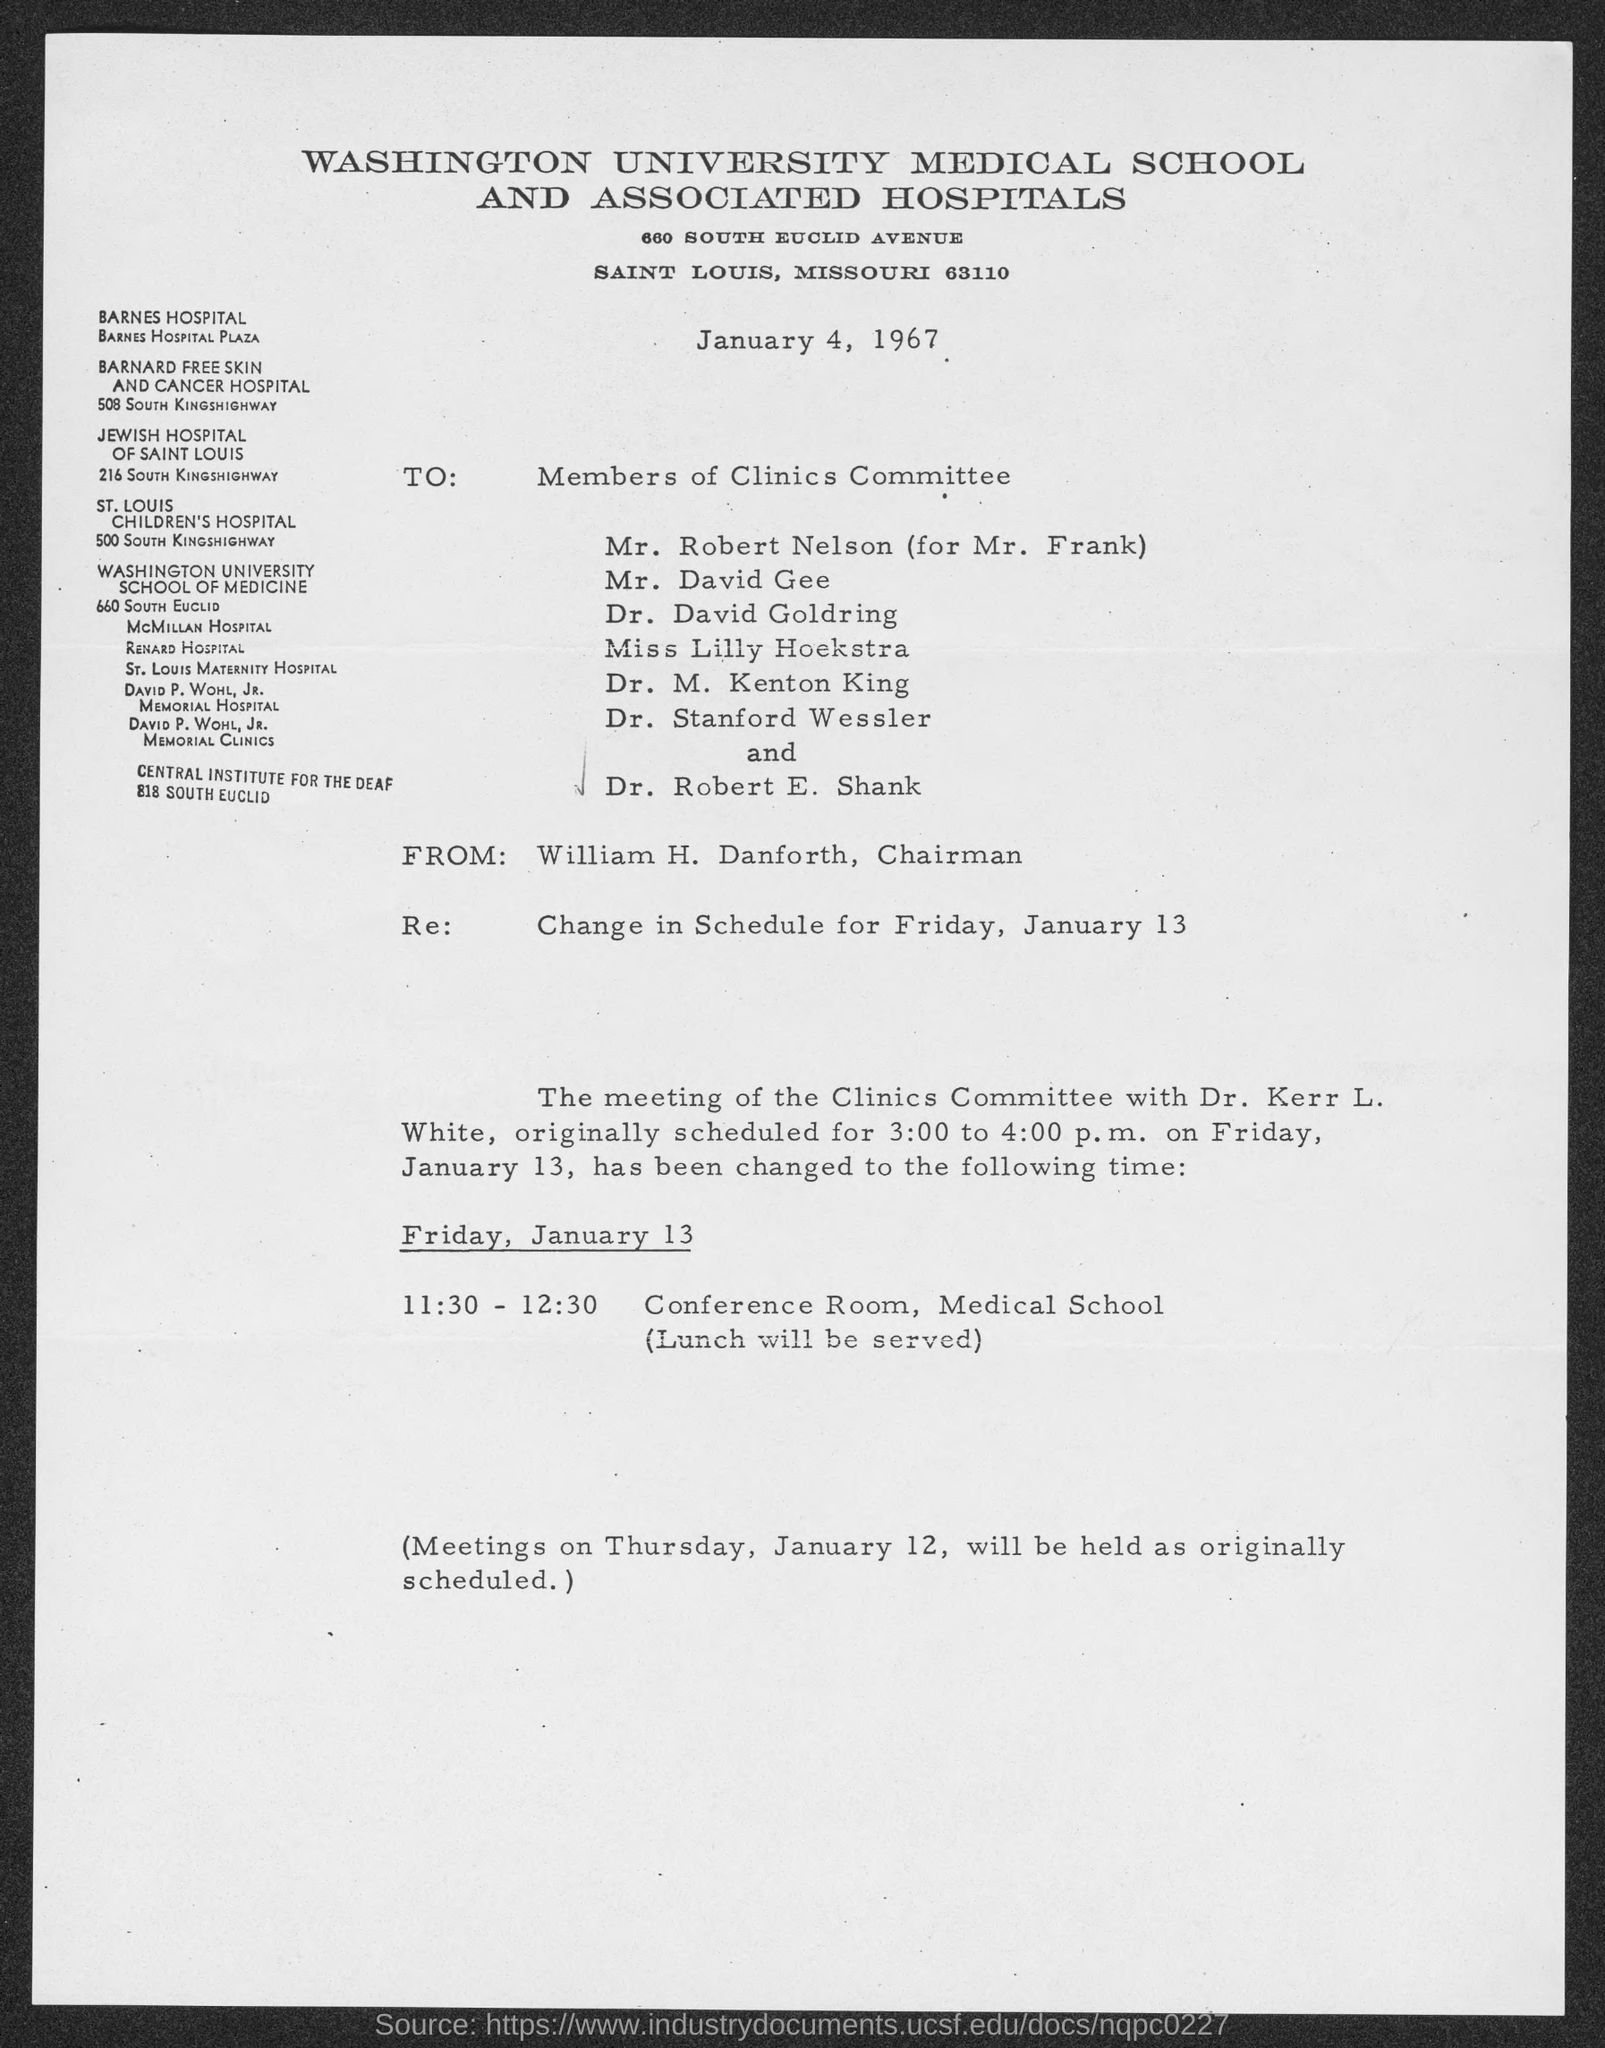When is the memorandum dated?
Keep it short and to the point. January 4, 1967. What is the position of william h. danforth ?
Ensure brevity in your answer.  Chairman. What is the subject of memorandum ?
Make the answer very short. Change in Schedule for Friday, January 13. What is the venue for meeting on friday, january 13?
Give a very brief answer. Conference Room, Medical School. 